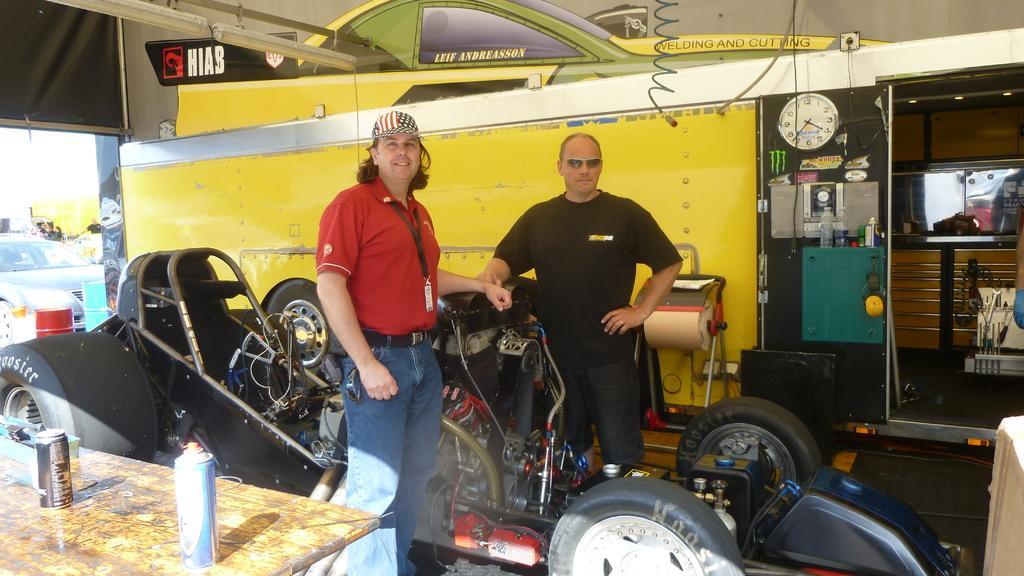Please provide a concise description of this image. In this picture we can see two men standing and smiling, vehicles, bottles, clock, tables, posters, barrels and some objects. 